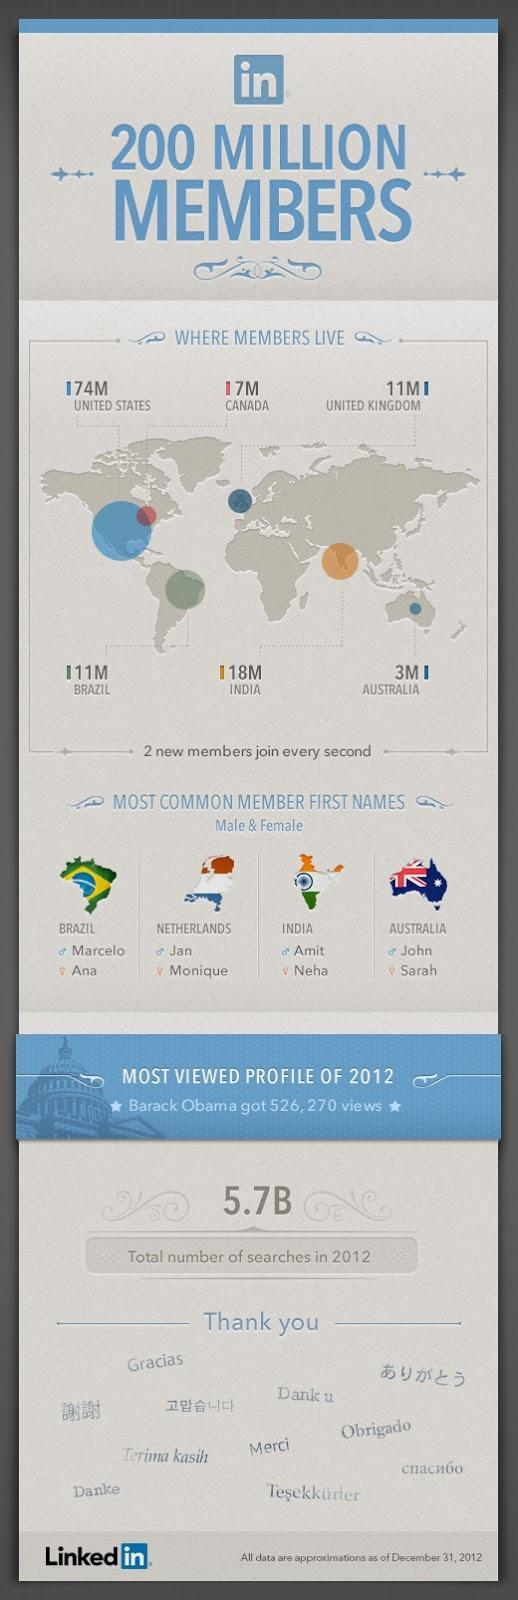In Netherlands, majority of the male LinkedIn members have which first name?
Answer the question with a short phrase. Jan How many LinkedIn members live in Australia? 3M Which country has about 7 million LinkedIn members? Canada How many LinkedIn members are from India? 18M Which is the most common first name for males from Australia? John In which country does the highest number of LinkedIn members live? United States The highest number of LinkedIn members are from which continent - North America, Europe or Asia? North America Which country has the same number of LinkedIn members as that of  United Kingdom? Brazil Marcelo is a common first name for users from which country? Brazil Neha is the most common first name for females from which country? India 